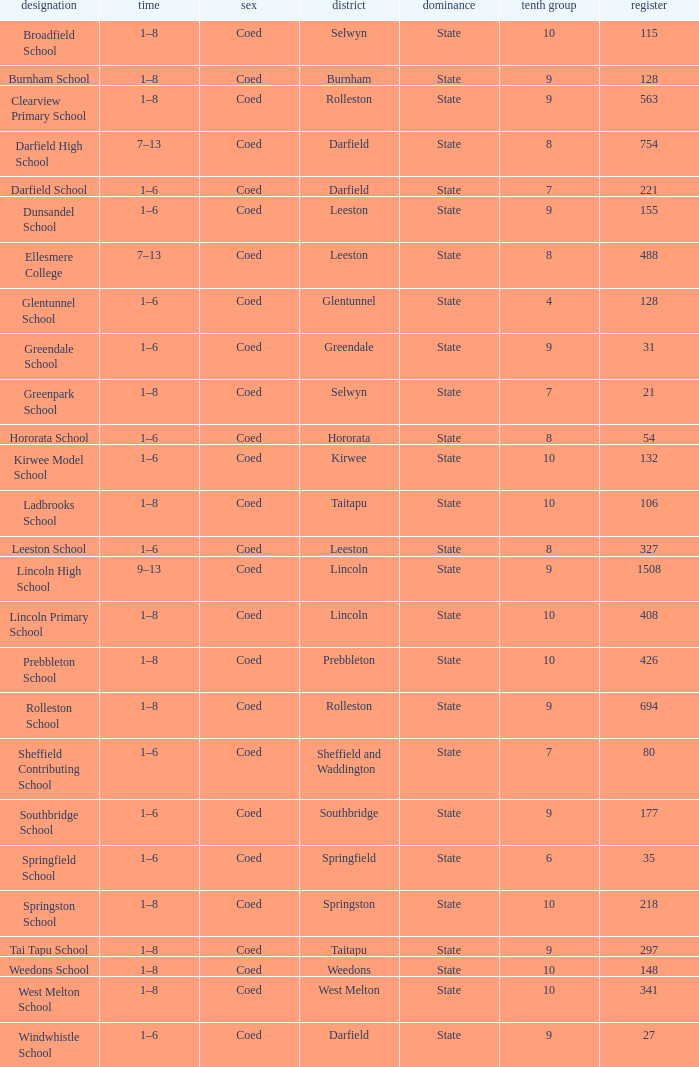What is the total of the roll with a Decile of 8, and an Area of hororata? 54.0. 